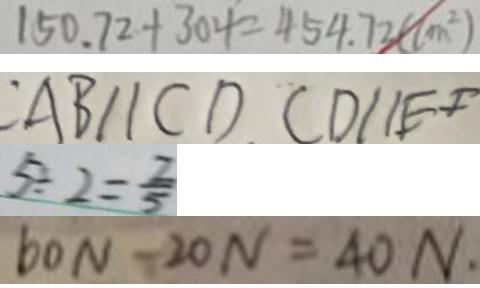Convert formula to latex. <formula><loc_0><loc_0><loc_500><loc_500>1 5 0 . 7 2 + 3 0 4 = 4 5 4 . 7 2 ( c m ^ { 2 } ) 
 : A B / / C D C D / / E F 
 5 \div 2 = \frac { 2 } { 5 } 
 6 0 N - 2 0 N = 4 0 N</formula> 